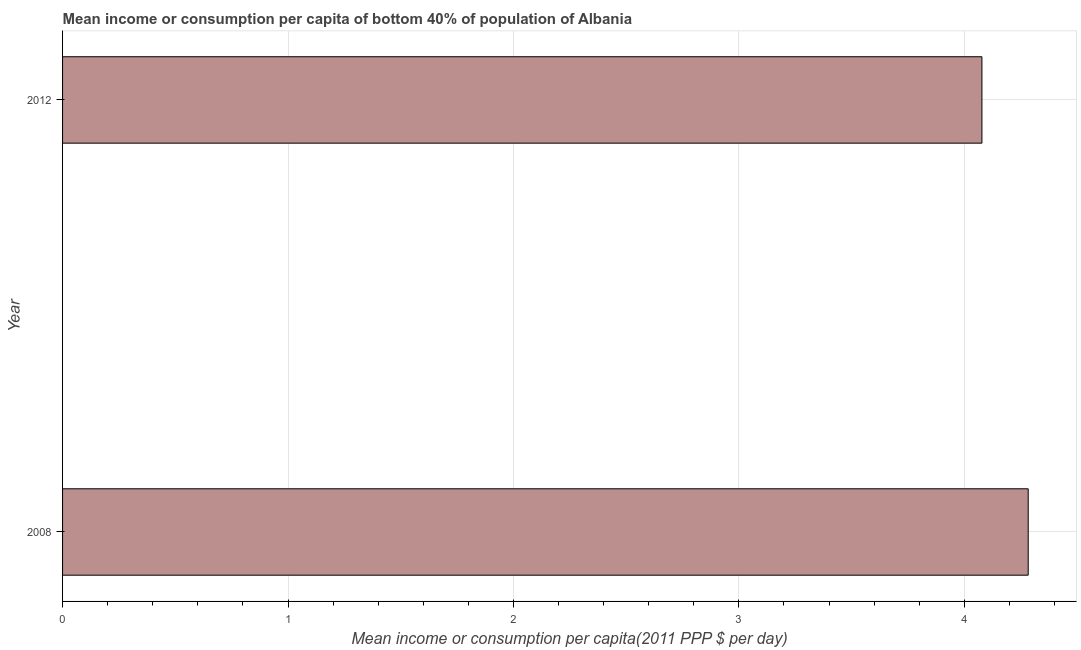What is the title of the graph?
Your answer should be compact. Mean income or consumption per capita of bottom 40% of population of Albania. What is the label or title of the X-axis?
Offer a very short reply. Mean income or consumption per capita(2011 PPP $ per day). What is the mean income or consumption in 2008?
Provide a short and direct response. 4.28. Across all years, what is the maximum mean income or consumption?
Your response must be concise. 4.28. Across all years, what is the minimum mean income or consumption?
Your answer should be very brief. 4.08. What is the sum of the mean income or consumption?
Offer a terse response. 8.36. What is the difference between the mean income or consumption in 2008 and 2012?
Offer a terse response. 0.2. What is the average mean income or consumption per year?
Your answer should be compact. 4.18. What is the median mean income or consumption?
Provide a short and direct response. 4.18. In how many years, is the mean income or consumption greater than 3 $?
Your response must be concise. 2. In how many years, is the mean income or consumption greater than the average mean income or consumption taken over all years?
Make the answer very short. 1. How many bars are there?
Make the answer very short. 2. Are all the bars in the graph horizontal?
Your response must be concise. Yes. What is the difference between two consecutive major ticks on the X-axis?
Ensure brevity in your answer.  1. Are the values on the major ticks of X-axis written in scientific E-notation?
Provide a succinct answer. No. What is the Mean income or consumption per capita(2011 PPP $ per day) of 2008?
Make the answer very short. 4.28. What is the Mean income or consumption per capita(2011 PPP $ per day) of 2012?
Offer a very short reply. 4.08. What is the difference between the Mean income or consumption per capita(2011 PPP $ per day) in 2008 and 2012?
Offer a very short reply. 0.21. 